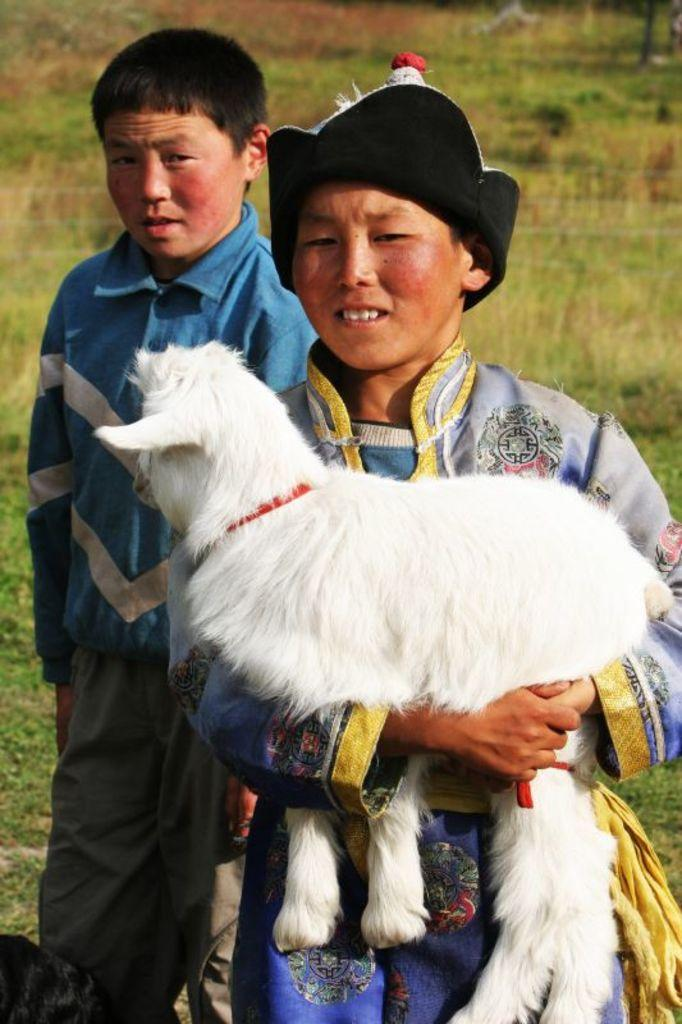How many people are in the image? There are two persons in the image. What is one person doing with an animal? One person is holding a dog. Can you describe the dog's appearance? The dog is white in color. What type of surface can be seen in the image? There is grass in the image. Can you tell me how many cups are on the table in the image? There is no table or cups present in the image. What type of space vehicle can be seen in the image? There is no space vehicle present in the image. 